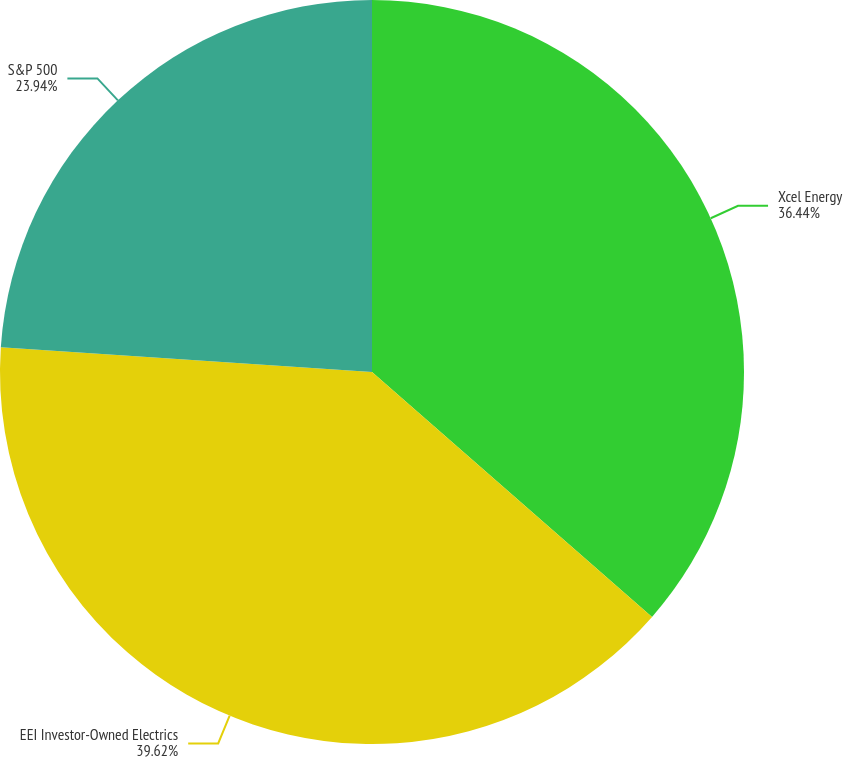<chart> <loc_0><loc_0><loc_500><loc_500><pie_chart><fcel>Xcel Energy<fcel>EEI Investor-Owned Electrics<fcel>S&P 500<nl><fcel>36.44%<fcel>39.63%<fcel>23.94%<nl></chart> 